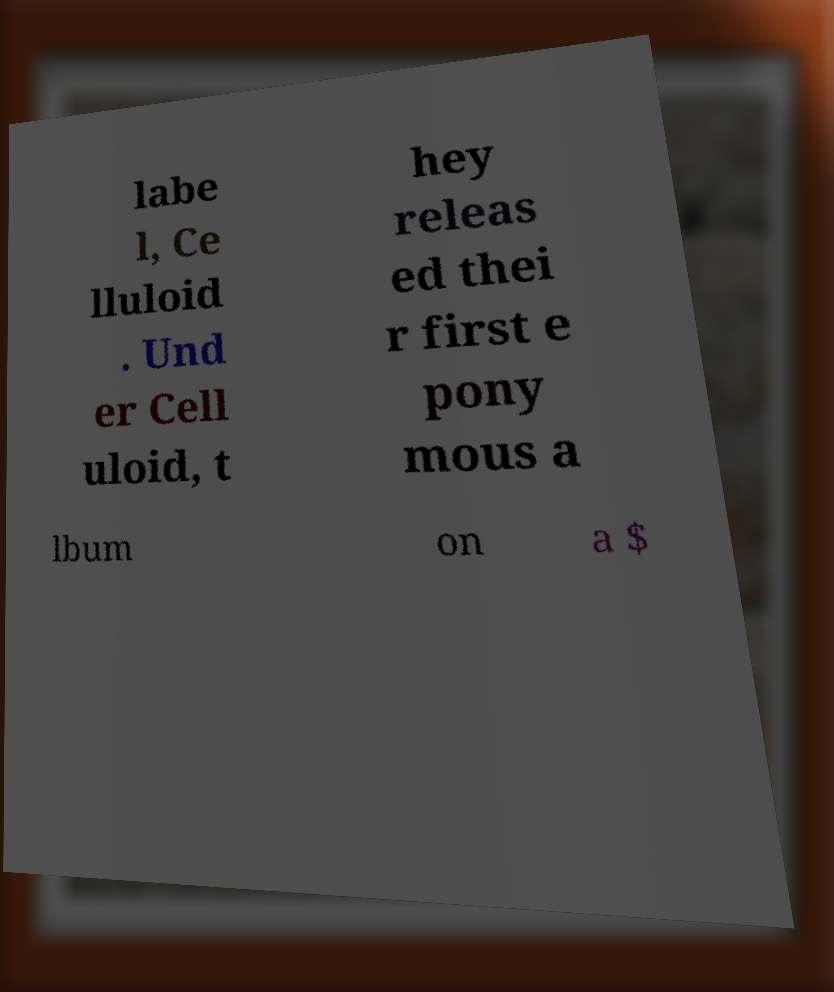Could you assist in decoding the text presented in this image and type it out clearly? labe l, Ce lluloid . Und er Cell uloid, t hey releas ed thei r first e pony mous a lbum on a $ 